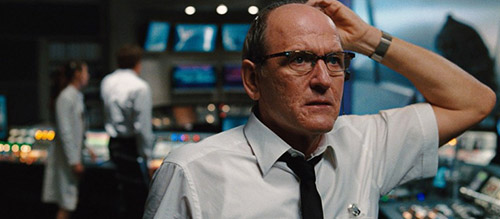Can you explain more about the significance of the setting in this image? Certainly! The setting of this image is a news control room, a pivotal area in news broadcasting where content is monitored, organized, and dispatched. This environment is integral to the operation of a news channel, showcasing how various elements like live feeds, editorial content, and coordination between different departments converge. The multiple screens, control panels, and the focused intensity of the workers underscore the constant, fast-paced decision-making that is crucial in shaping public information and perception. 